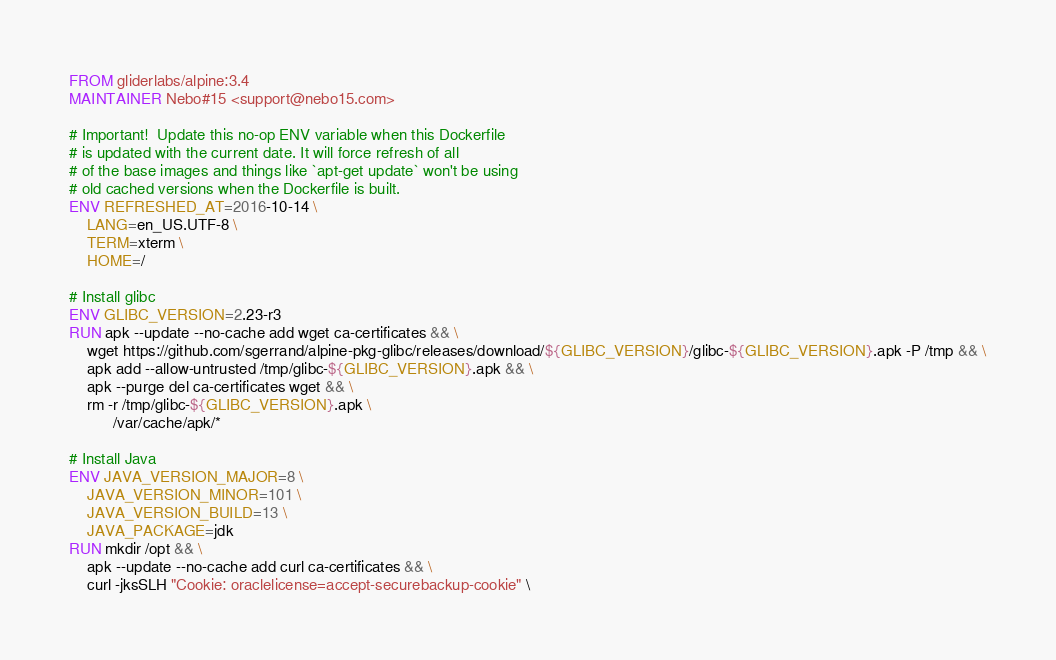Convert code to text. <code><loc_0><loc_0><loc_500><loc_500><_Dockerfile_>FROM gliderlabs/alpine:3.4
MAINTAINER Nebo#15 <support@nebo15.com>

# Important!  Update this no-op ENV variable when this Dockerfile
# is updated with the current date. It will force refresh of all
# of the base images and things like `apt-get update` won't be using
# old cached versions when the Dockerfile is built.
ENV REFRESHED_AT=2016-10-14 \
    LANG=en_US.UTF-8 \
    TERM=xterm \
    HOME=/

# Install glibc
ENV GLIBC_VERSION=2.23-r3
RUN apk --update --no-cache add wget ca-certificates && \
    wget https://github.com/sgerrand/alpine-pkg-glibc/releases/download/${GLIBC_VERSION}/glibc-${GLIBC_VERSION}.apk -P /tmp && \
    apk add --allow-untrusted /tmp/glibc-${GLIBC_VERSION}.apk && \
    apk --purge del ca-certificates wget && \
    rm -r /tmp/glibc-${GLIBC_VERSION}.apk \
          /var/cache/apk/*

# Install Java
ENV JAVA_VERSION_MAJOR=8 \
    JAVA_VERSION_MINOR=101 \
    JAVA_VERSION_BUILD=13 \
    JAVA_PACKAGE=jdk
RUN mkdir /opt && \
    apk --update --no-cache add curl ca-certificates && \
    curl -jksSLH "Cookie: oraclelicense=accept-securebackup-cookie" \</code> 